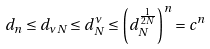Convert formula to latex. <formula><loc_0><loc_0><loc_500><loc_500>d _ { n } \leq d _ { \nu N } \leq d _ { N } ^ { \nu } \leq \left ( d _ { N } ^ { \frac { 1 } { 2 N } } \right ) ^ { n } = c ^ { n }</formula> 